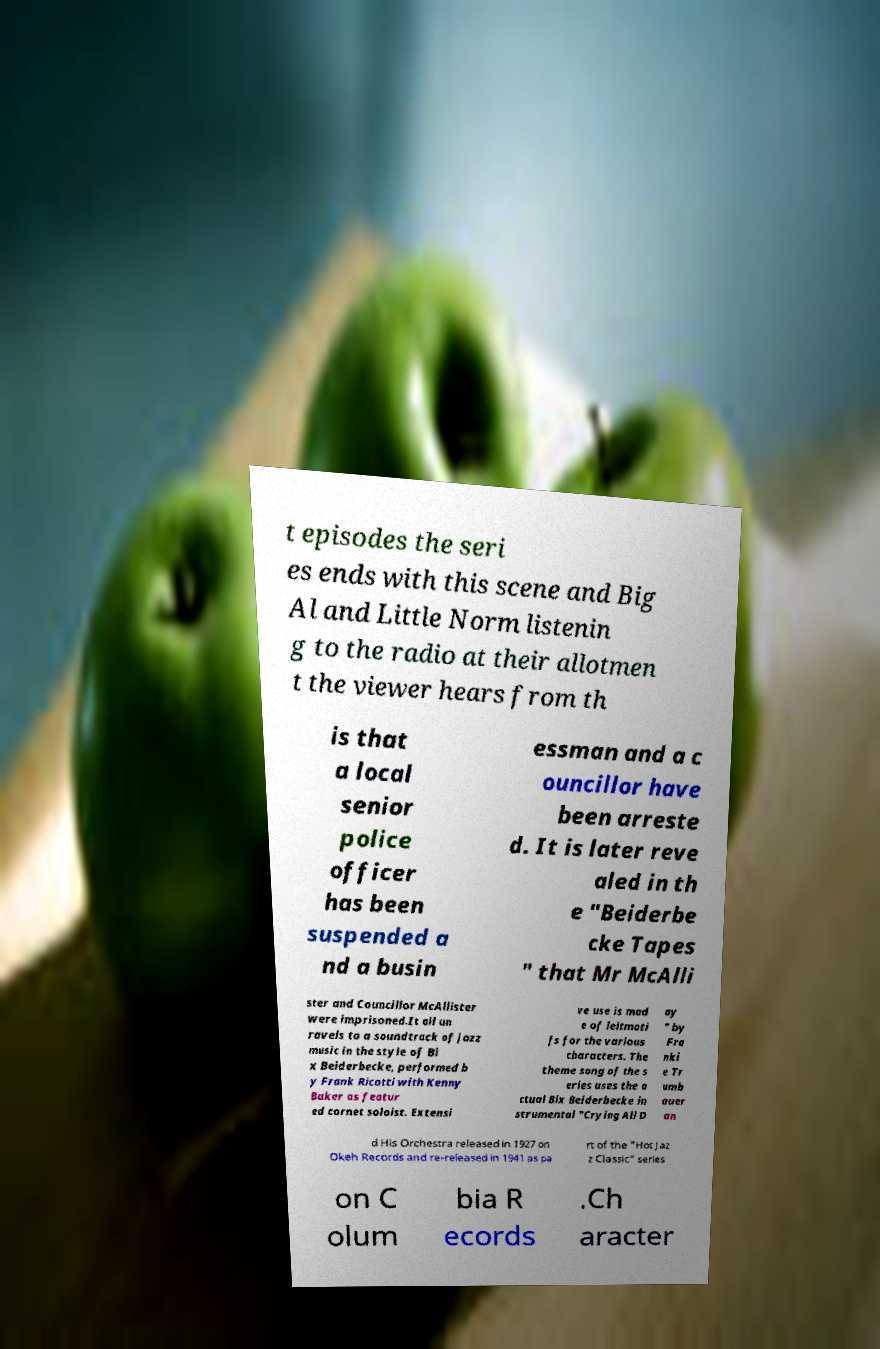Please read and relay the text visible in this image. What does it say? t episodes the seri es ends with this scene and Big Al and Little Norm listenin g to the radio at their allotmen t the viewer hears from th is that a local senior police officer has been suspended a nd a busin essman and a c ouncillor have been arreste d. It is later reve aled in th e "Beiderbe cke Tapes " that Mr McAlli ster and Councillor McAllister were imprisoned.It all un ravels to a soundtrack of jazz music in the style of Bi x Beiderbecke, performed b y Frank Ricotti with Kenny Baker as featur ed cornet soloist. Extensi ve use is mad e of leitmoti fs for the various characters. The theme song of the s eries uses the a ctual Bix Beiderbecke in strumental "Crying All D ay " by Fra nki e Tr umb auer an d His Orchestra released in 1927 on Okeh Records and re-released in 1941 as pa rt of the "Hot Jaz z Classic" series on C olum bia R ecords .Ch aracter 